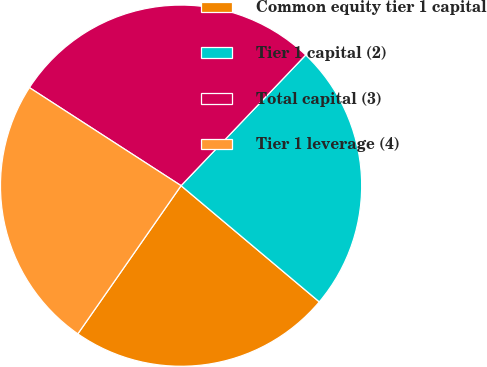Convert chart. <chart><loc_0><loc_0><loc_500><loc_500><pie_chart><fcel>Common equity tier 1 capital<fcel>Tier 1 capital (2)<fcel>Total capital (3)<fcel>Tier 1 leverage (4)<nl><fcel>23.56%<fcel>24.0%<fcel>27.99%<fcel>24.45%<nl></chart> 